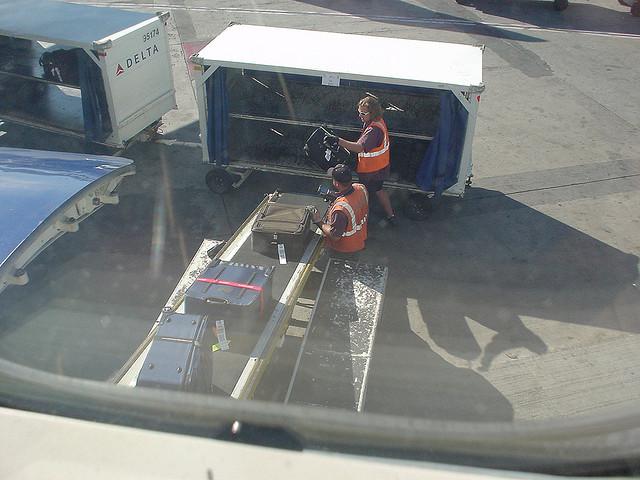What are these people loading?
Be succinct. Luggage. What is the woman in the hat looking at?
Give a very brief answer. Luggage. Why are they wearing the vest?
Answer briefly. Safety. What company do they work for?
Give a very brief answer. Delta. 